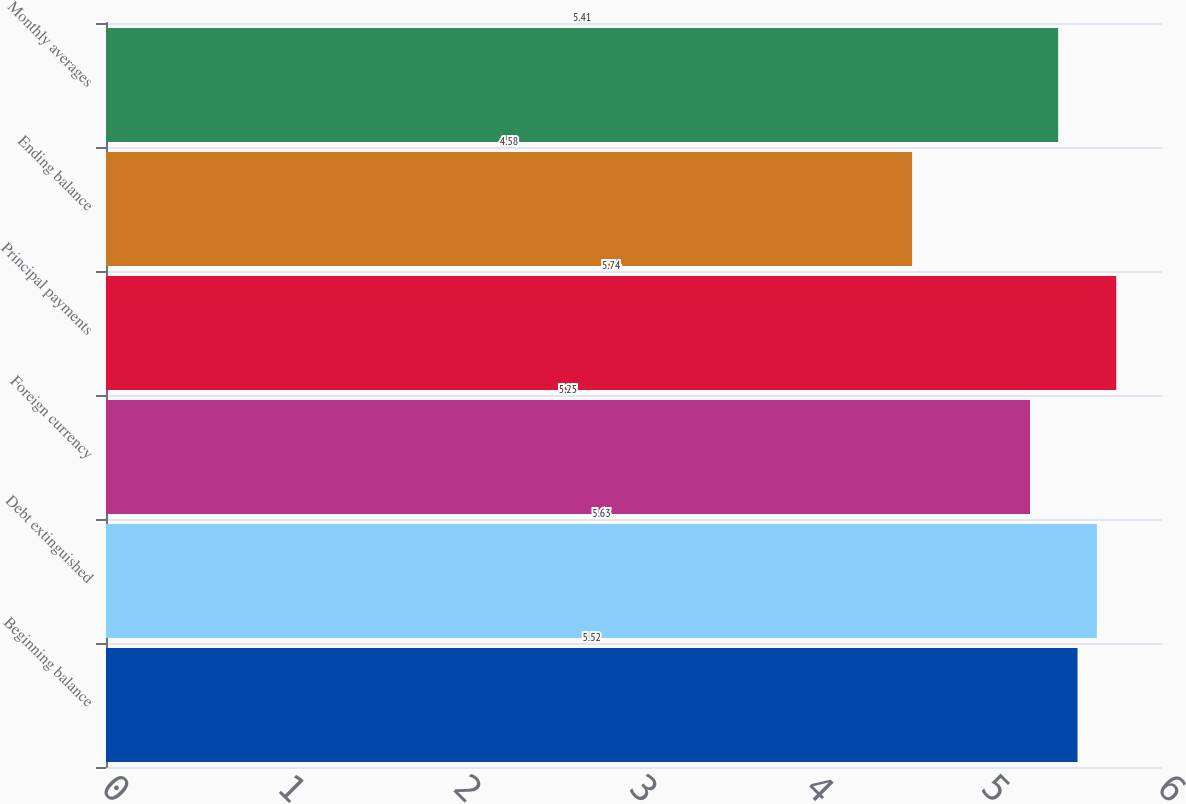Convert chart to OTSL. <chart><loc_0><loc_0><loc_500><loc_500><bar_chart><fcel>Beginning balance<fcel>Debt extinguished<fcel>Foreign currency<fcel>Principal payments<fcel>Ending balance<fcel>Monthly averages<nl><fcel>5.52<fcel>5.63<fcel>5.25<fcel>5.74<fcel>4.58<fcel>5.41<nl></chart> 